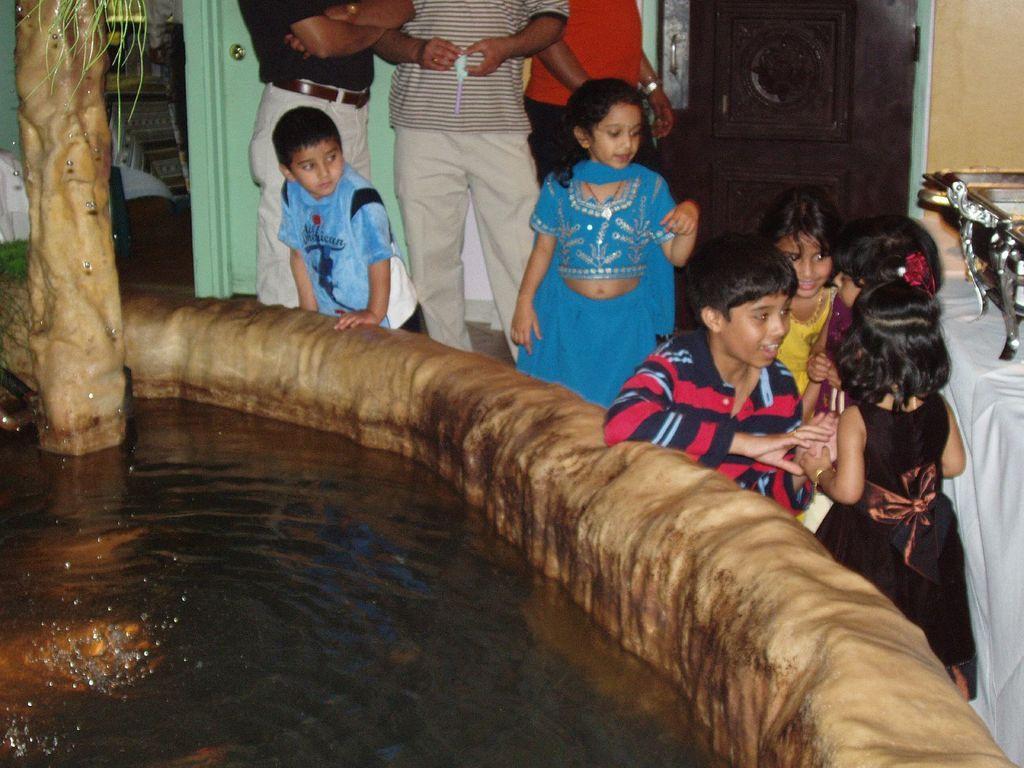How would you summarize this image in a sentence or two? In this image, we can see kids beside the water tank. There is a table on the right side of the image contains dishes. There are three persons at the top of the image standing in front of the wall. There is a door in the top right of the image. There is a stem on the left side of the image. 